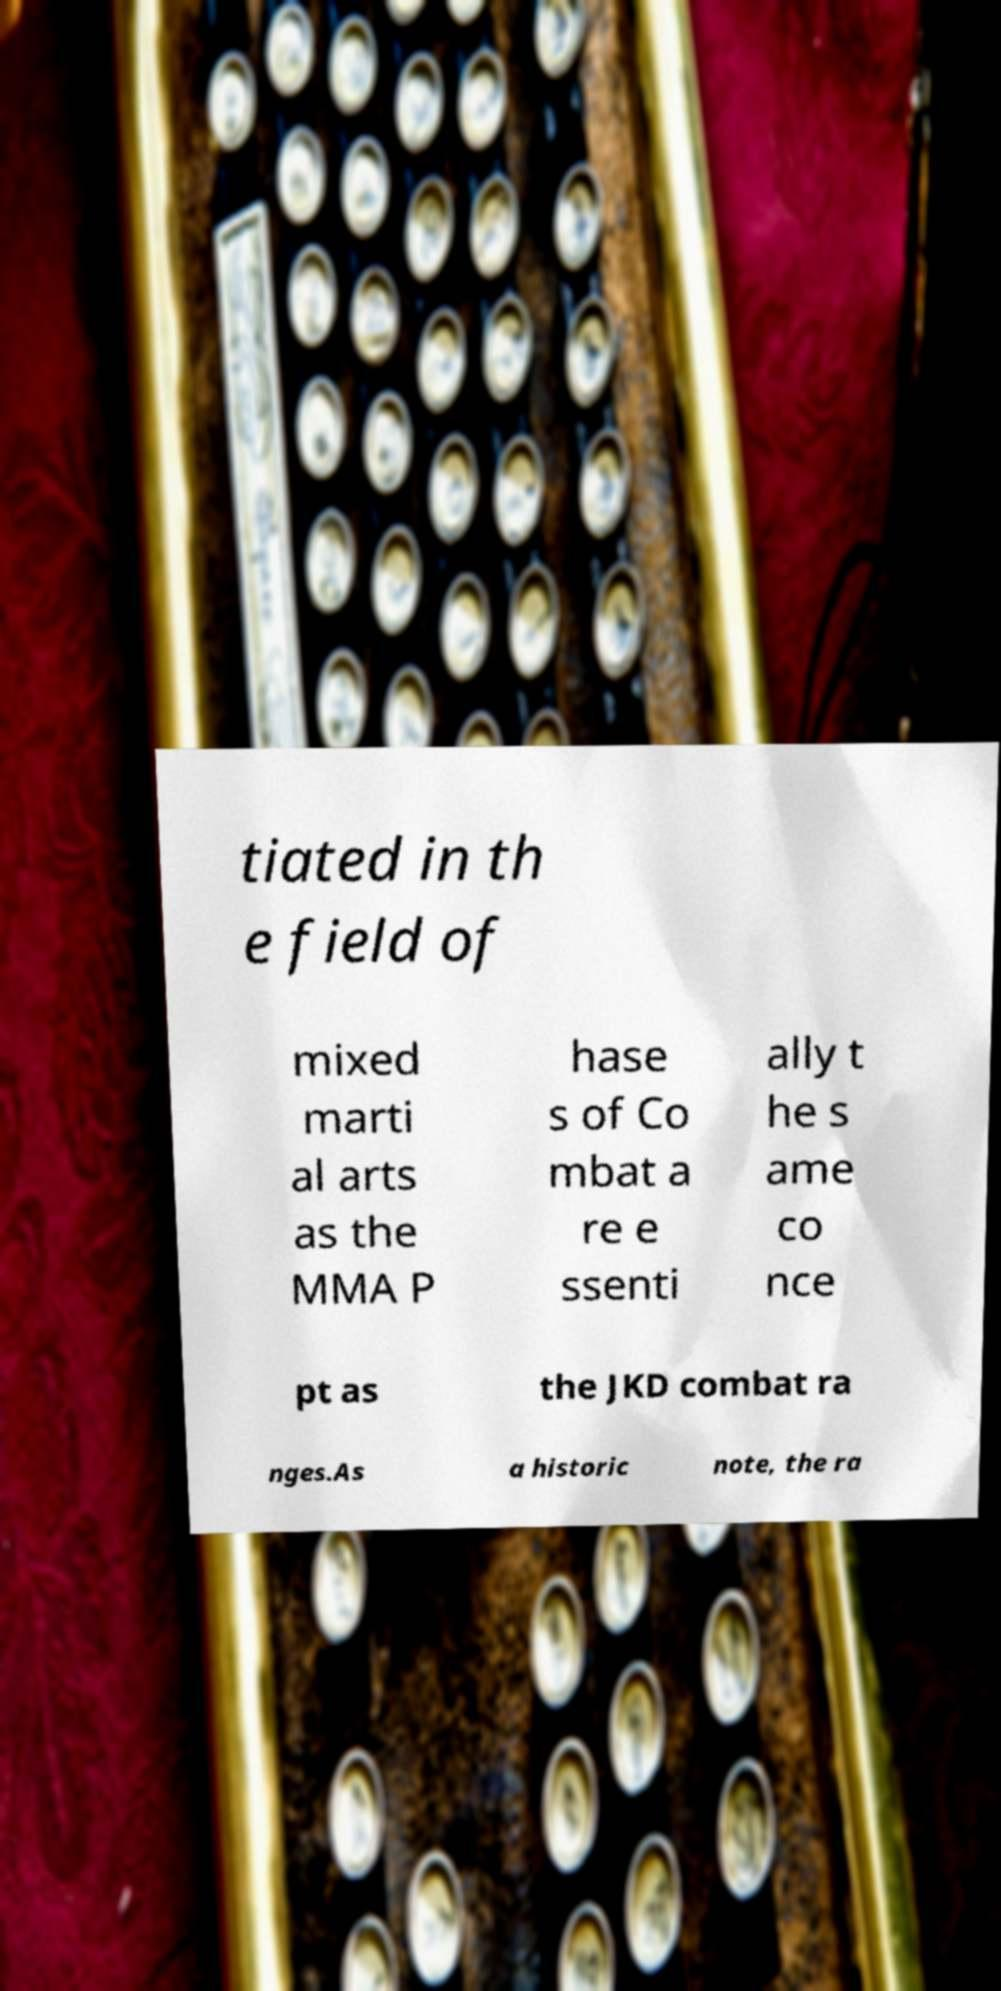Please identify and transcribe the text found in this image. tiated in th e field of mixed marti al arts as the MMA P hase s of Co mbat a re e ssenti ally t he s ame co nce pt as the JKD combat ra nges.As a historic note, the ra 